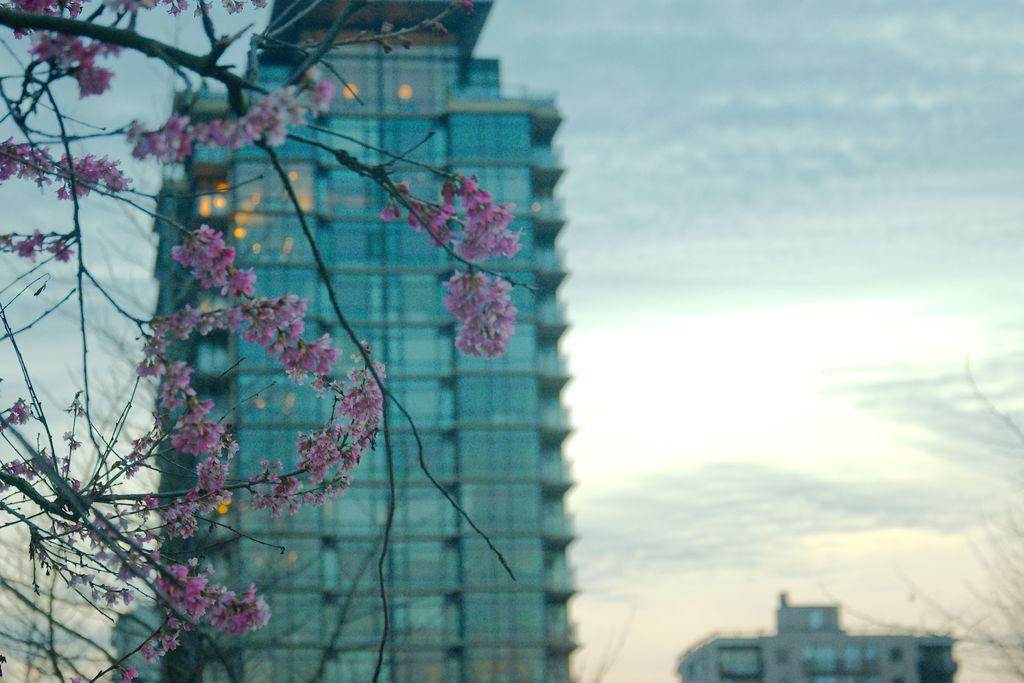Please provide a concise description of this image. On the left side we can see a plant with flowers. In the background we can see buildings,glass doors and clouds in the sky. 